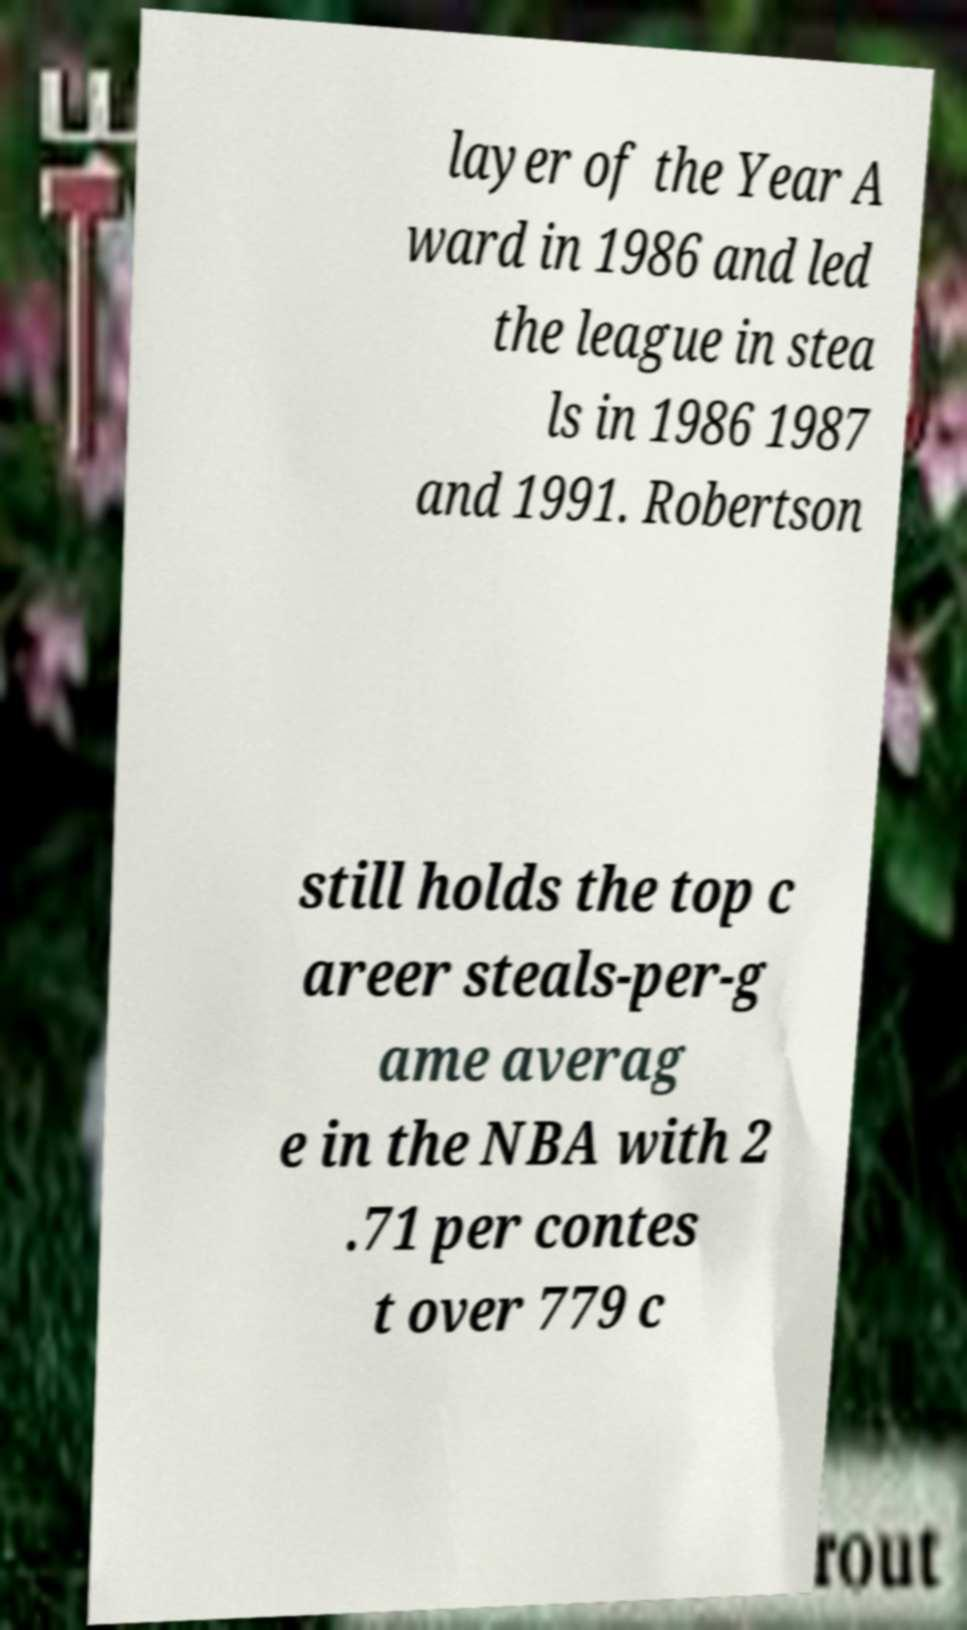Please read and relay the text visible in this image. What does it say? layer of the Year A ward in 1986 and led the league in stea ls in 1986 1987 and 1991. Robertson still holds the top c areer steals-per-g ame averag e in the NBA with 2 .71 per contes t over 779 c 